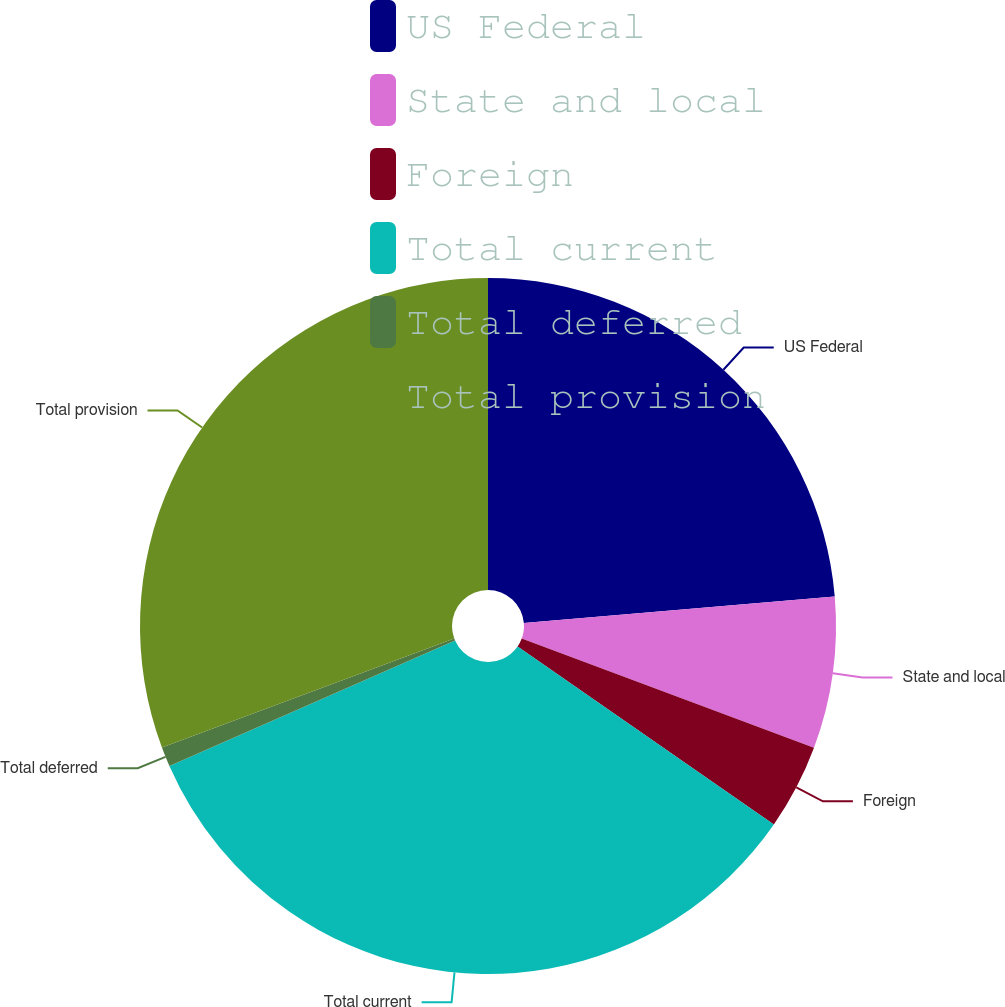Convert chart. <chart><loc_0><loc_0><loc_500><loc_500><pie_chart><fcel>US Federal<fcel>State and local<fcel>Foreign<fcel>Total current<fcel>Total deferred<fcel>Total provision<nl><fcel>23.65%<fcel>7.04%<fcel>3.97%<fcel>33.75%<fcel>0.91%<fcel>30.68%<nl></chart> 